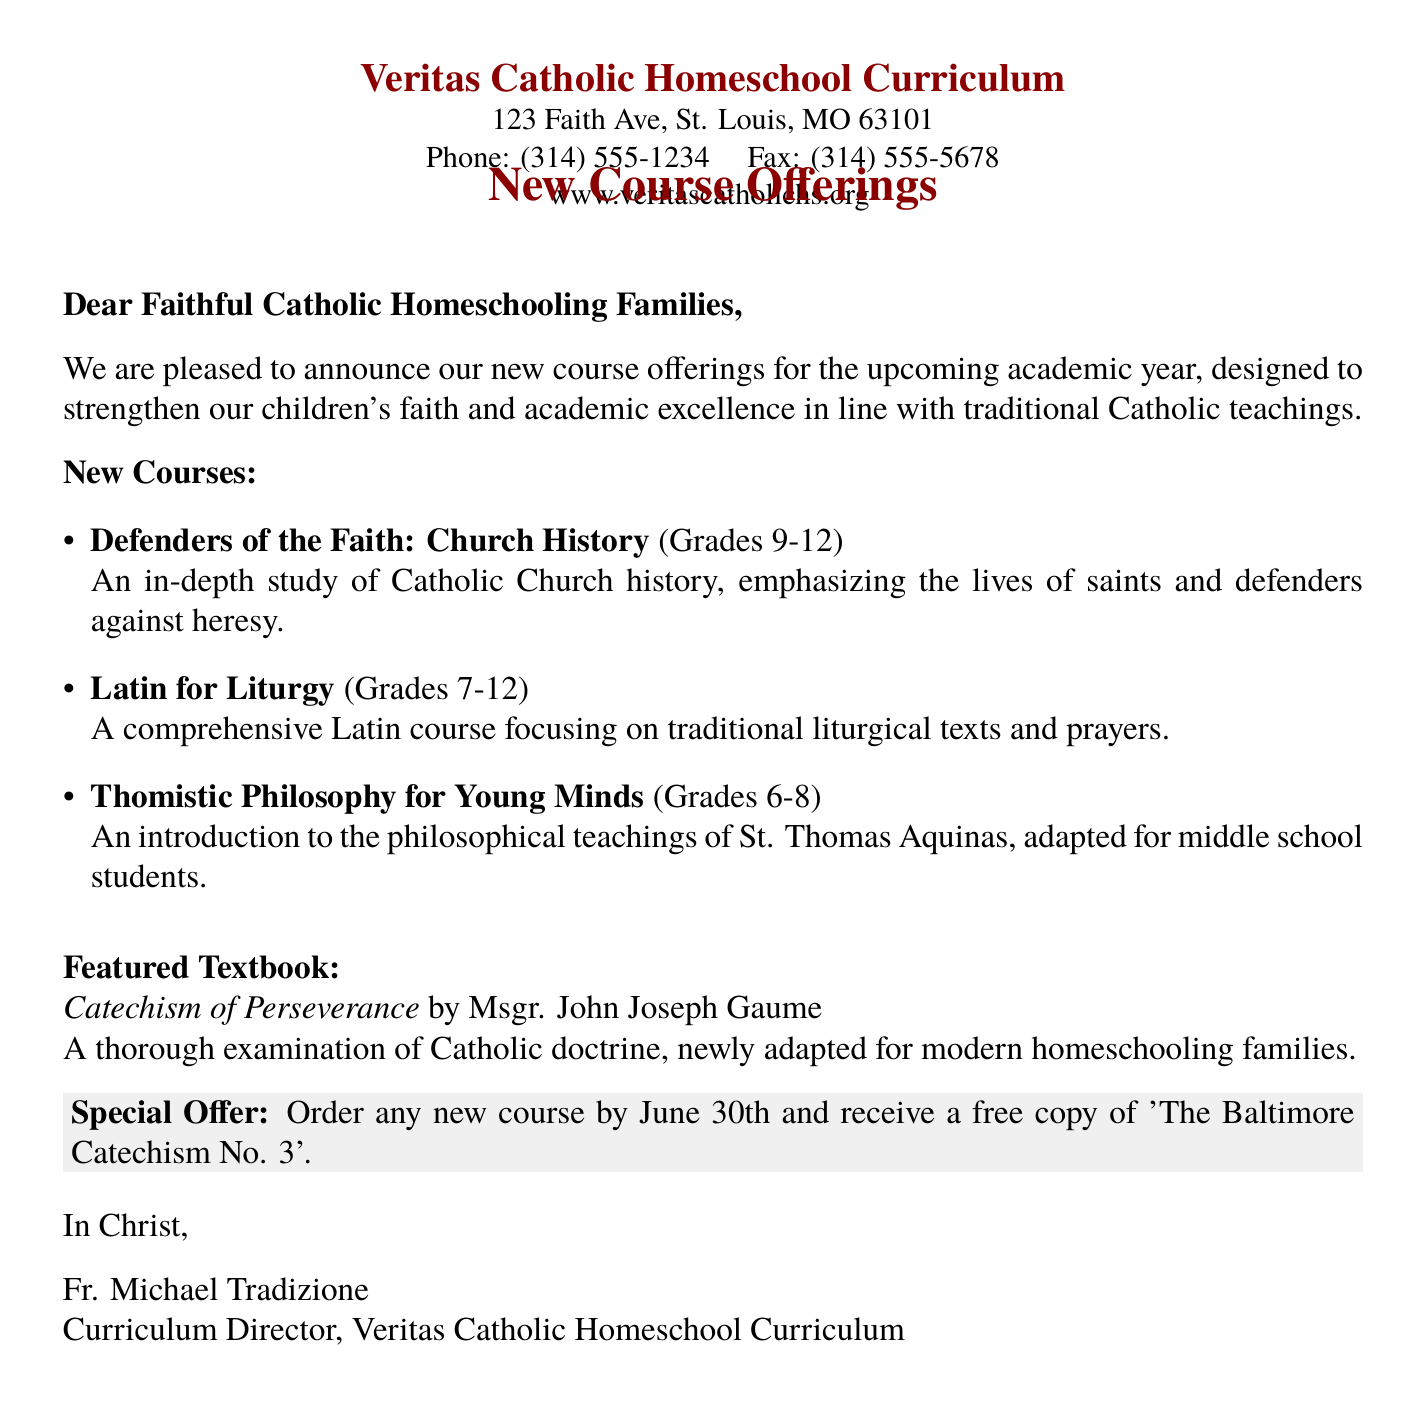What is the name of the curriculum provider? The document begins with "Veritas Catholic Homeschool Curriculum" indicating the provider's name.
Answer: Veritas Catholic Homeschool Curriculum What is the address of the curriculum provider? The address is mentioned as "123 Faith Ave, St. Louis, MO 63101".
Answer: 123 Faith Ave, St. Louis, MO 63101 Who is the Curriculum Director? The sign-off indicates that "Fr. Michael Tradizione" is the Curriculum Director.
Answer: Fr. Michael Tradizione What is the special offer deadline? The document states that orders need to be placed "by June 30th" to receive a special offer.
Answer: June 30th What is the featured textbook? The featured textbook is titled "Catechism of Perseverance" by Msgr. John Joseph Gaume.
Answer: Catechism of Perseverance Which grade levels are included in "Defenders of the Faith: Church History"? The course is designed for "Grades 9-12" as specified in the document.
Answer: Grades 9-12 What is the focus of the "Latin for Liturgy" course? The course emphasizes "traditional liturgical texts and prayers" as stated in the description.
Answer: traditional liturgical texts and prayers How many new courses are announced in the document? The list itemizes three new courses offered this academic year.
Answer: Three What is the philosophical teaching mentioned in the new courses? The course "Thomistic Philosophy for Young Minds" refers to the teachings of "St. Thomas Aquinas".
Answer: St. Thomas Aquinas 